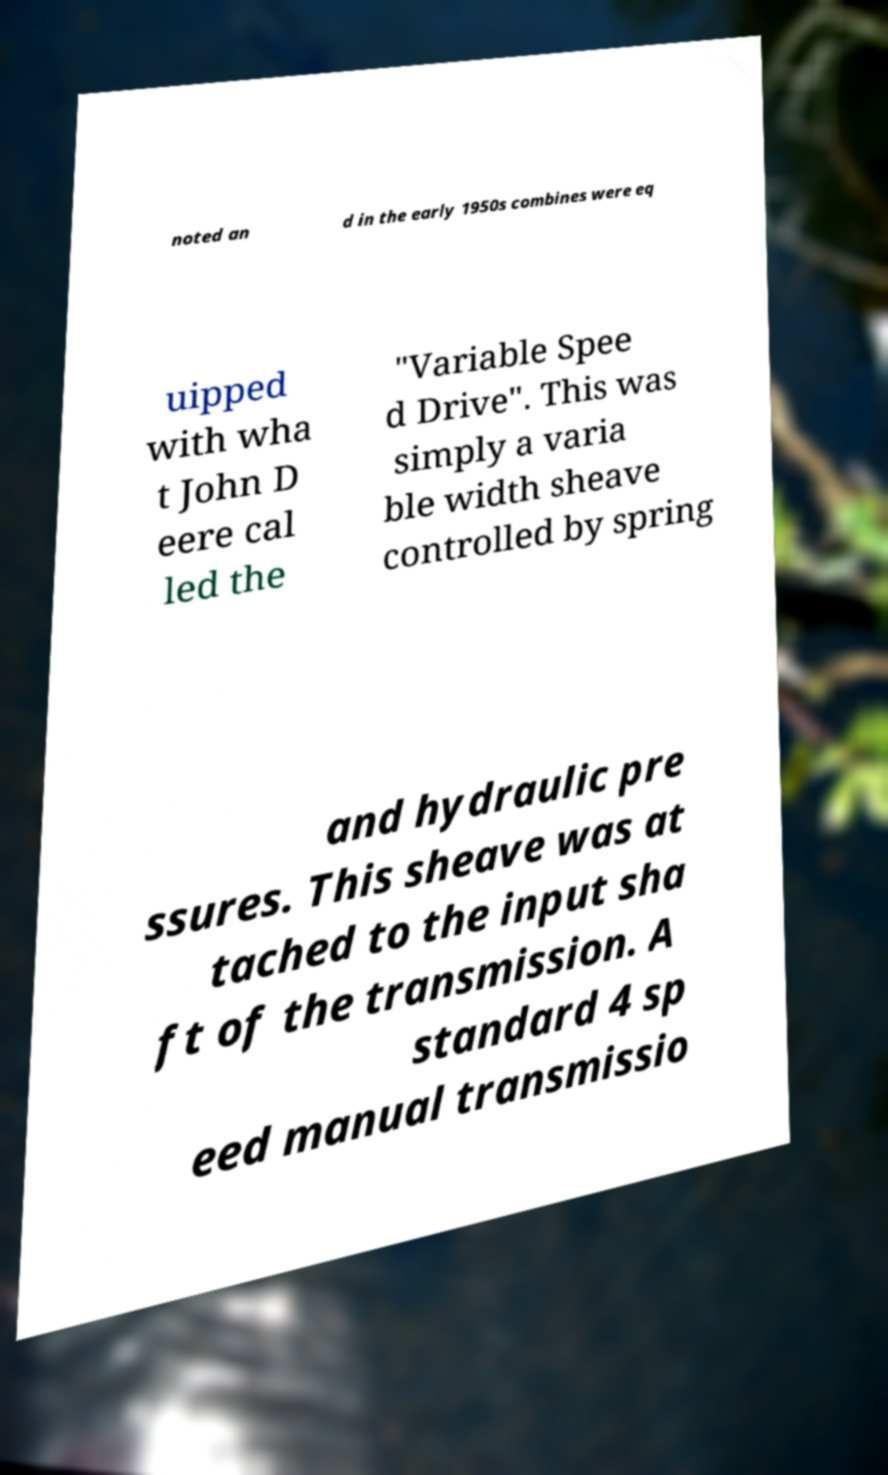Can you accurately transcribe the text from the provided image for me? noted an d in the early 1950s combines were eq uipped with wha t John D eere cal led the "Variable Spee d Drive". This was simply a varia ble width sheave controlled by spring and hydraulic pre ssures. This sheave was at tached to the input sha ft of the transmission. A standard 4 sp eed manual transmissio 